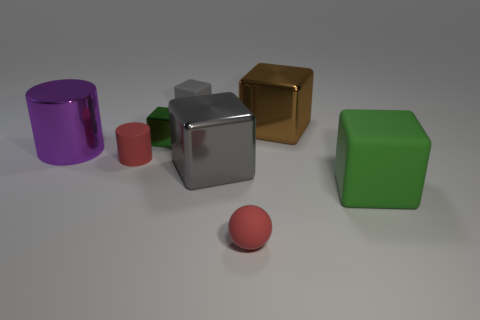What is the material of the tiny block that is the same color as the big matte cube?
Your answer should be compact. Metal. How many matte things are on the right side of the small red thing that is on the right side of the gray block that is in front of the small gray block?
Offer a very short reply. 1. There is a small red rubber cylinder; how many objects are in front of it?
Your answer should be very brief. 3. What number of tiny blocks have the same material as the red cylinder?
Your response must be concise. 1. What color is the big cube that is made of the same material as the brown thing?
Your answer should be very brief. Gray. What is the material of the gray cube behind the large cube behind the object to the left of the rubber cylinder?
Provide a succinct answer. Rubber. There is a red object to the left of the sphere; is it the same size as the large gray thing?
Your answer should be compact. No. How many large objects are purple spheres or metal cylinders?
Your answer should be very brief. 1. Are there any matte cylinders that have the same color as the small sphere?
Make the answer very short. Yes. There is a red object that is the same size as the ball; what is its shape?
Your answer should be very brief. Cylinder. 